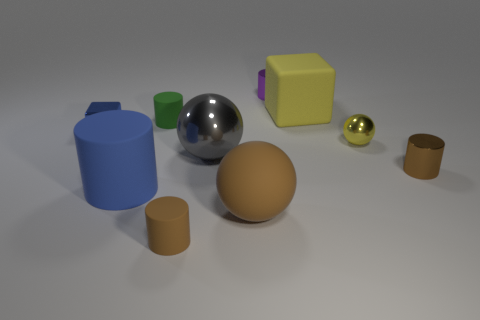How big is the block that is behind the cube left of the brown cylinder left of the tiny purple metallic cylinder?
Provide a succinct answer. Large. Do the gray ball and the brown rubber ball have the same size?
Give a very brief answer. Yes. What number of things are big yellow objects or tiny cylinders?
Your answer should be very brief. 5. What is the size of the rubber cylinder on the right side of the matte cylinder that is behind the large blue matte cylinder?
Your answer should be very brief. Small. The purple cylinder has what size?
Your answer should be compact. Small. There is a tiny object that is both in front of the gray metallic thing and right of the large brown ball; what shape is it?
Offer a very short reply. Cylinder. There is another object that is the same shape as the large yellow object; what color is it?
Your answer should be compact. Blue. What number of things are small brown cylinders that are on the left side of the large brown sphere or brown matte things to the left of the matte sphere?
Offer a terse response. 1. The large blue object is what shape?
Keep it short and to the point. Cylinder. The rubber thing that is the same color as the large rubber sphere is what shape?
Ensure brevity in your answer.  Cylinder. 